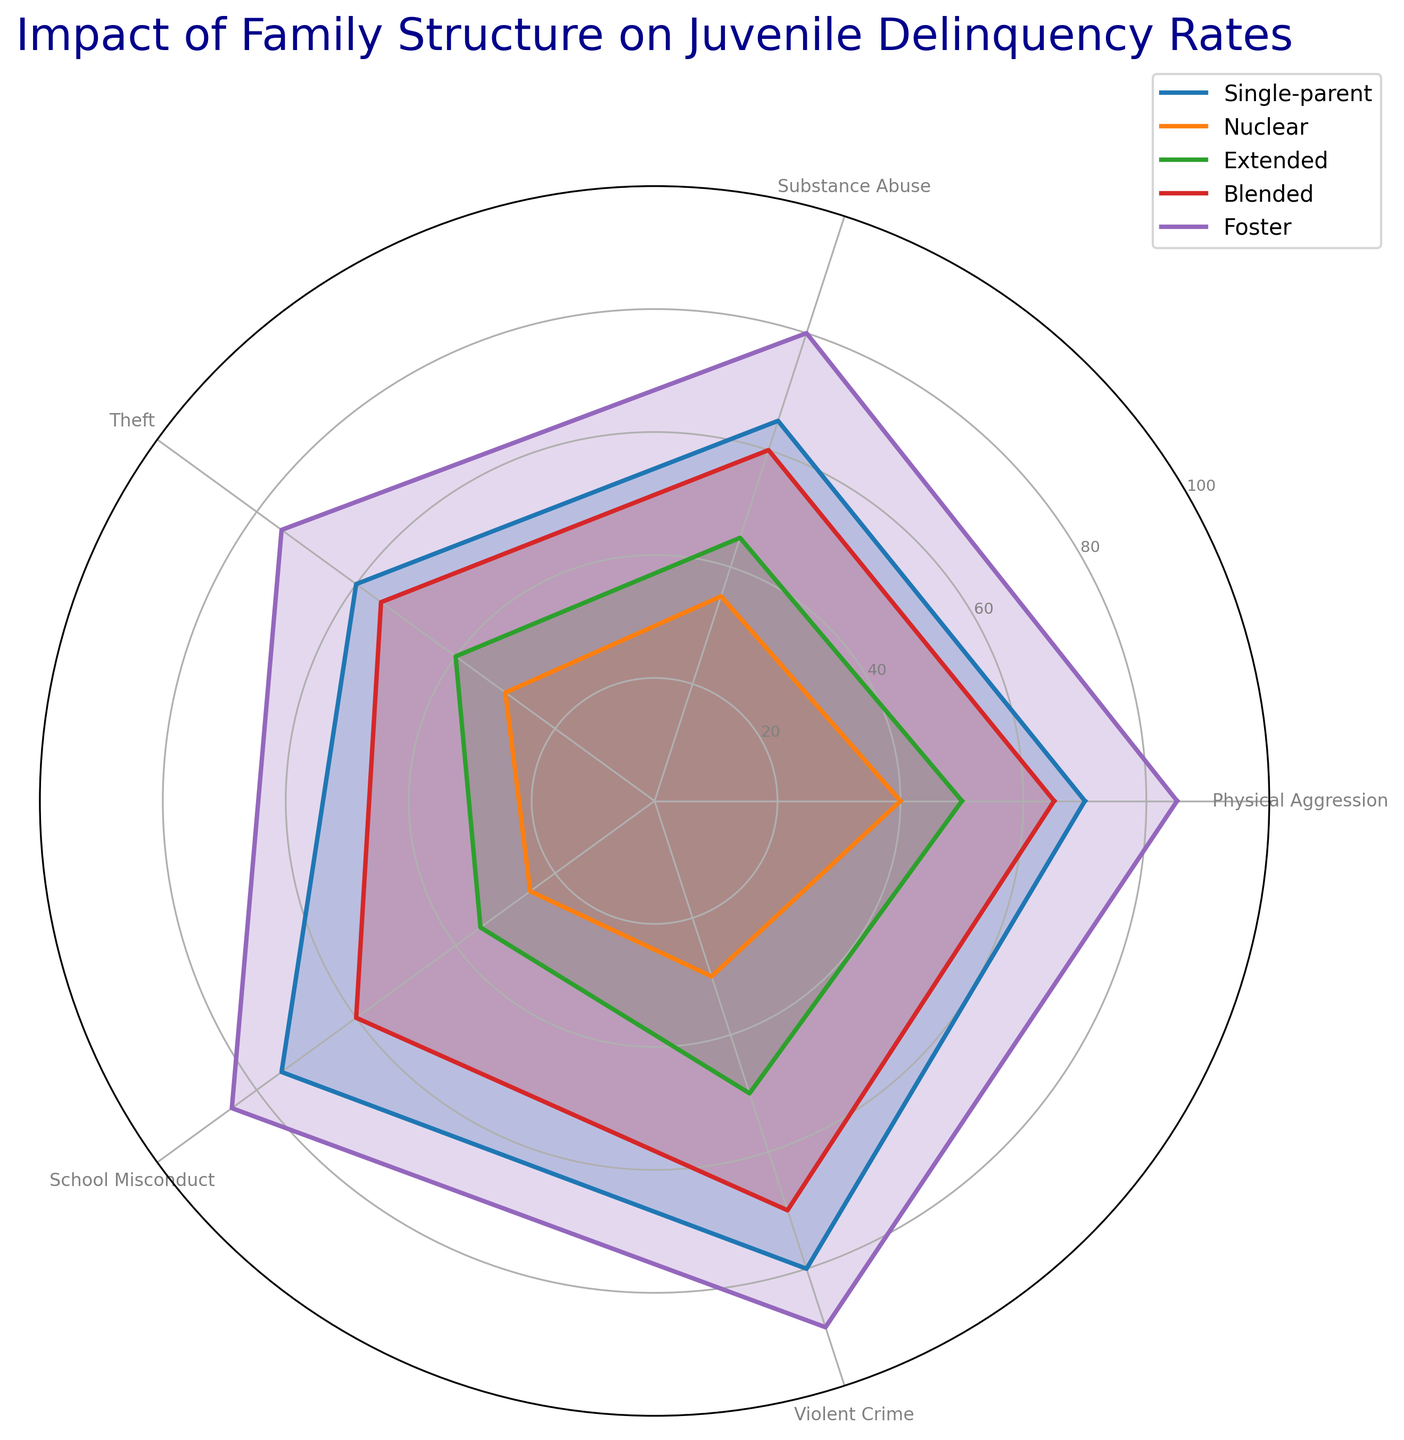Which family structure has the highest rate of theft? Look at the 'Theft' axis on the radar chart and find which family structure extends furthest. The Foster structure extends furthest.
Answer: Foster How does the rate of physical aggression in a single-parent family compare to that in a nuclear family? Compare the values at the 'Physical Aggression' axis; Single-parent is at 70 and Nuclear is at 40.
Answer: Single-parent is higher Which family structures have similar rates of school misconduct? Look at the 'School Misconduct' axis for similar lengths; Blended at 60 and Extended at 60.
Answer: Blended and Extended What is the average rate of substance abuse across all family structures? Sum up the values of substance abuse (65 + 35 + 45 + 60 + 80 = 285) and divide by the number of family structures (5). Average = 285 / 5.
Answer: 57 Which family structure shows the least violent crime rate? Look at the 'Violent Crime' axis and find which family structure extends the least. Nuclear extends the least.
Answer: Nuclear Is the rate of theft in a blended family higher than that in an extended family? Compare the theft rates; Blended is at 55, Extended is at 40.
Answer: Yes What is the difference in physical aggression rates between foster and nuclear families? Subtract the physical aggression rate of nuclear (40) from that of foster (85). Difference = 85 - 40.
Answer: 45 Which family structure has an average delinquency rate (across all categories) closest to 50? Calculate the average delinquency rate for each family structure.
Single-parent: (70+65+60+75+80) / 5 = 70
Nuclear: (40+35+30+25+30) / 5 = 32
Extended: (50+45+40+35+50) / 5 = 44
Blended: (65+60+55+60+70) / 5 = 62
Foster: (85+80+75+85+90) / 5 = 83
Closest to 50 is the Extended family at 44.
Answer: Extended What is the median value of theft rates across all family structures? Rank the theft rates (60, 30, 40, 55, 75) and select the middle value. Ordered: 30, 40, 55, 60, 75; median = 55.
Answer: 55 Which family structure has the steepest decline from school misconduct to violent crime rates? Check the 'School Misconduct' to 'Violent Crime' axis segments, Nuclear declines from 25 to 30 (a drop of 5), Single-parent changes from 75 to 80 (a drop of 5), and so on.
Answer: Nuclear 